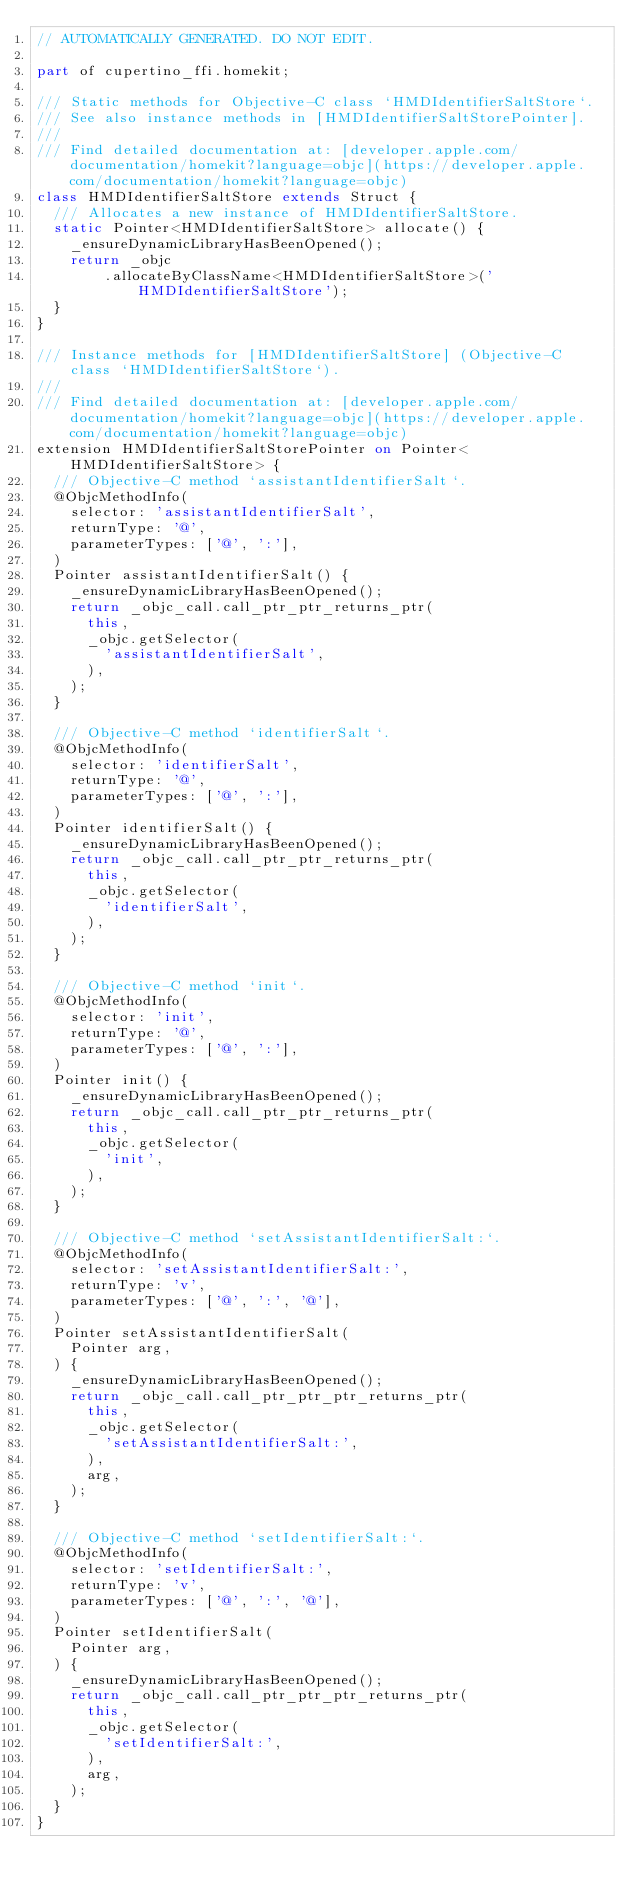<code> <loc_0><loc_0><loc_500><loc_500><_Dart_>// AUTOMATICALLY GENERATED. DO NOT EDIT.

part of cupertino_ffi.homekit;

/// Static methods for Objective-C class `HMDIdentifierSaltStore`.
/// See also instance methods in [HMDIdentifierSaltStorePointer].
///
/// Find detailed documentation at: [developer.apple.com/documentation/homekit?language=objc](https://developer.apple.com/documentation/homekit?language=objc)
class HMDIdentifierSaltStore extends Struct {
  /// Allocates a new instance of HMDIdentifierSaltStore.
  static Pointer<HMDIdentifierSaltStore> allocate() {
    _ensureDynamicLibraryHasBeenOpened();
    return _objc
        .allocateByClassName<HMDIdentifierSaltStore>('HMDIdentifierSaltStore');
  }
}

/// Instance methods for [HMDIdentifierSaltStore] (Objective-C class `HMDIdentifierSaltStore`).
///
/// Find detailed documentation at: [developer.apple.com/documentation/homekit?language=objc](https://developer.apple.com/documentation/homekit?language=objc)
extension HMDIdentifierSaltStorePointer on Pointer<HMDIdentifierSaltStore> {
  /// Objective-C method `assistantIdentifierSalt`.
  @ObjcMethodInfo(
    selector: 'assistantIdentifierSalt',
    returnType: '@',
    parameterTypes: ['@', ':'],
  )
  Pointer assistantIdentifierSalt() {
    _ensureDynamicLibraryHasBeenOpened();
    return _objc_call.call_ptr_ptr_returns_ptr(
      this,
      _objc.getSelector(
        'assistantIdentifierSalt',
      ),
    );
  }

  /// Objective-C method `identifierSalt`.
  @ObjcMethodInfo(
    selector: 'identifierSalt',
    returnType: '@',
    parameterTypes: ['@', ':'],
  )
  Pointer identifierSalt() {
    _ensureDynamicLibraryHasBeenOpened();
    return _objc_call.call_ptr_ptr_returns_ptr(
      this,
      _objc.getSelector(
        'identifierSalt',
      ),
    );
  }

  /// Objective-C method `init`.
  @ObjcMethodInfo(
    selector: 'init',
    returnType: '@',
    parameterTypes: ['@', ':'],
  )
  Pointer init() {
    _ensureDynamicLibraryHasBeenOpened();
    return _objc_call.call_ptr_ptr_returns_ptr(
      this,
      _objc.getSelector(
        'init',
      ),
    );
  }

  /// Objective-C method `setAssistantIdentifierSalt:`.
  @ObjcMethodInfo(
    selector: 'setAssistantIdentifierSalt:',
    returnType: 'v',
    parameterTypes: ['@', ':', '@'],
  )
  Pointer setAssistantIdentifierSalt(
    Pointer arg,
  ) {
    _ensureDynamicLibraryHasBeenOpened();
    return _objc_call.call_ptr_ptr_ptr_returns_ptr(
      this,
      _objc.getSelector(
        'setAssistantIdentifierSalt:',
      ),
      arg,
    );
  }

  /// Objective-C method `setIdentifierSalt:`.
  @ObjcMethodInfo(
    selector: 'setIdentifierSalt:',
    returnType: 'v',
    parameterTypes: ['@', ':', '@'],
  )
  Pointer setIdentifierSalt(
    Pointer arg,
  ) {
    _ensureDynamicLibraryHasBeenOpened();
    return _objc_call.call_ptr_ptr_ptr_returns_ptr(
      this,
      _objc.getSelector(
        'setIdentifierSalt:',
      ),
      arg,
    );
  }
}
</code> 